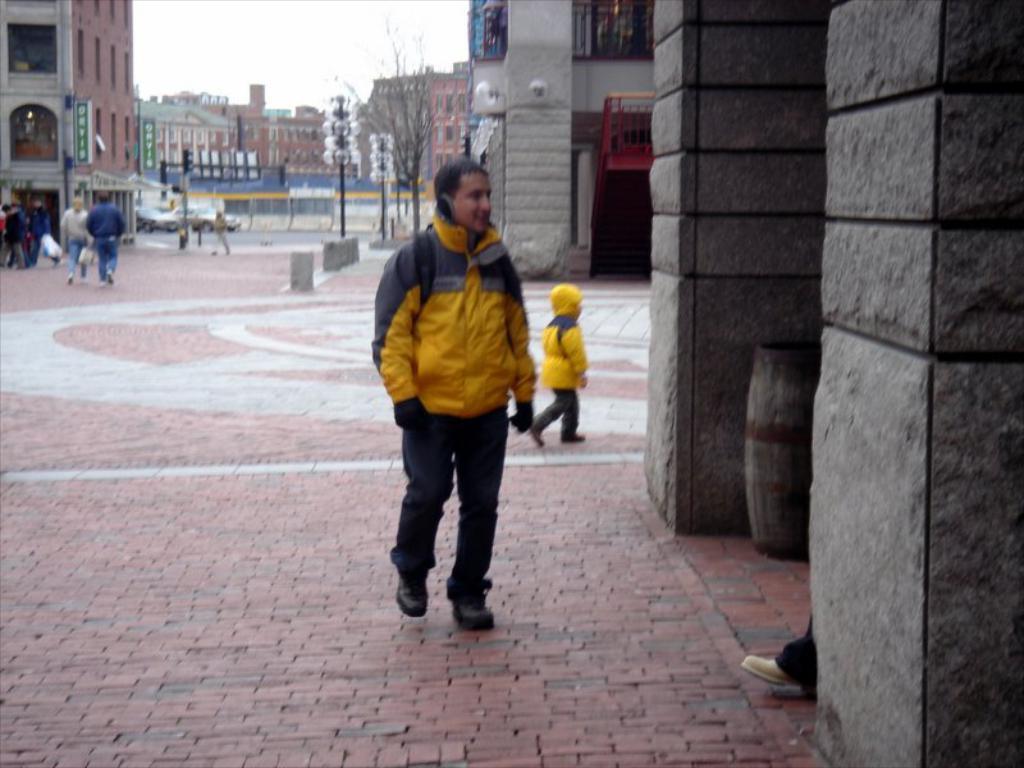How would you summarize this image in a sentence or two? This picture is clicked outside the city. At the bottom, we see the pavement. In front of the picture, we see a man in the yellow jacket is walking. Behind him, we see a boy in the yellow jacket is walking. On the right side, we see the walls in grey color which are made up of stones. Beside that, we see a garbage bin and the leg of the person. On the left side, we see two people are walking. Beside them, we see the people are standing. Behind them, we see a building in white and brown color. Beside that, we see the traffic signals and poles. Beside that, we see a man is walking. Behind him, we see the vehicles are moving on the road. In the background, we see the trees, buildings and poles. At the top, we see the sky. 